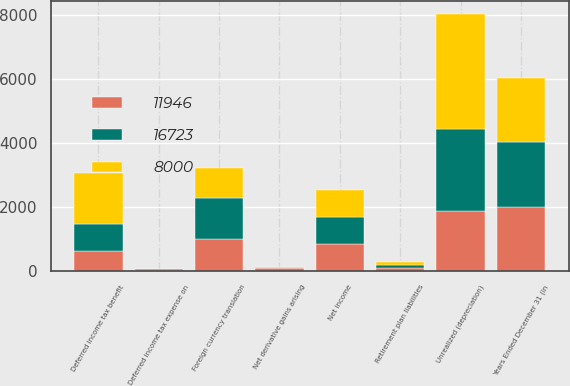Convert chart. <chart><loc_0><loc_0><loc_500><loc_500><stacked_bar_chart><ecel><fcel>Years Ended December 31 (in<fcel>Net income<fcel>Unrealized (depreciation)<fcel>Deferred income tax benefit<fcel>Foreign currency translation<fcel>Net derivative gains arising<fcel>Deferred income tax expense on<fcel>Retirement plan liabilities<nl><fcel>16723<fcel>2006<fcel>839<fcel>2574<fcel>839<fcel>1283<fcel>13<fcel>15<fcel>80<nl><fcel>8000<fcel>2005<fcel>839<fcel>3577<fcel>1599<fcel>926<fcel>35<fcel>7<fcel>81<nl><fcel>11946<fcel>2004<fcel>839<fcel>1868<fcel>612<fcel>993<fcel>83<fcel>33<fcel>100<nl></chart> 